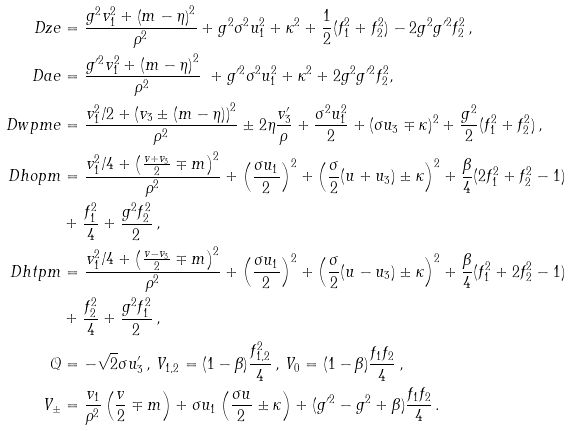<formula> <loc_0><loc_0><loc_500><loc_500>\ D z e & = \frac { g ^ { 2 } v _ { 1 } ^ { 2 } + \left ( m - \eta \right ) ^ { 2 } } { \rho ^ { 2 } } + g ^ { 2 } \sigma ^ { 2 } u _ { 1 } ^ { 2 } + \kappa ^ { 2 } + \frac { 1 } { 2 } ( f _ { 1 } ^ { 2 } + f _ { 2 } ^ { 2 } ) - 2 g ^ { 2 } g ^ { \prime 2 } f _ { 2 } ^ { 2 } \, , \\ \ D a e & = \frac { g ^ { \prime 2 } v _ { 1 } ^ { 2 } + \left ( m - \eta \right ) ^ { 2 } } { \rho ^ { 2 } } \ + g ^ { \prime 2 } \sigma ^ { 2 } u _ { 1 } ^ { 2 } + \kappa ^ { 2 } + 2 g ^ { 2 } g ^ { \prime 2 } f _ { 2 } ^ { 2 } , \\ \ D w p m e & = \frac { v _ { 1 } ^ { 2 } / 2 + \left ( v _ { 3 } \pm ( m - \eta ) \right ) ^ { 2 } } { \rho ^ { 2 } } \pm 2 \eta \frac { v _ { 3 } ^ { \prime } } { \rho } + \frac { \sigma ^ { 2 } u _ { 1 } ^ { 2 } } { 2 } + ( \sigma u _ { 3 } \mp \kappa ) ^ { 2 } + \frac { g ^ { 2 } } { 2 } ( f _ { 1 } ^ { 2 } + f _ { 2 } ^ { 2 } ) \, , \\ \ D h o p m & = \frac { v _ { 1 } ^ { 2 } / 4 + \left ( \frac { v + v _ { 3 } } { 2 } \mp m \right ) ^ { 2 } } { \rho ^ { 2 } } + \left ( \frac { \sigma u _ { 1 } } { 2 } \right ) ^ { 2 } + \left ( \frac { \sigma } { 2 } ( u + u _ { 3 } ) \pm \kappa \right ) ^ { 2 } + \frac { \beta } { 4 } ( 2 f _ { 1 } ^ { 2 } + f _ { 2 } ^ { 2 } - 1 ) \\ & + \frac { f _ { 1 } ^ { 2 } } { 4 } + \frac { g ^ { 2 } f _ { 2 } ^ { 2 } } { 2 } \, , \\ \ D h t p m & = \frac { v _ { 1 } ^ { 2 } / 4 + \left ( \frac { v - v _ { 3 } } { 2 } \mp m \right ) ^ { 2 } } { \rho ^ { 2 } } + \left ( \frac { \sigma u _ { 1 } } { 2 } \right ) ^ { 2 } + \left ( \frac { \sigma } { 2 } ( u - u _ { 3 } ) \pm \kappa \right ) ^ { 2 } + \frac { \beta } { 4 } ( f _ { 1 } ^ { 2 } + 2 f _ { 2 } ^ { 2 } - 1 ) \\ & + \frac { f _ { 2 } ^ { 2 } } { 4 } + \frac { g ^ { 2 } f _ { 1 } ^ { 2 } } { 2 } \, , \\ \mathcal { Q } & = - \sqrt { 2 } \sigma u _ { 3 } ^ { \prime } \, , \, V _ { 1 , 2 } = ( 1 - \beta ) \frac { f _ { 1 , 2 } ^ { 2 } } { 4 } \, , \, V _ { 0 } = ( 1 - \beta ) \frac { f _ { 1 } f _ { 2 } } { 4 } \, , \\ V _ { \pm } & = \frac { v _ { 1 } } { \rho ^ { 2 } } \left ( \frac { v } { 2 } \mp m \right ) + \sigma u _ { 1 } \left ( \frac { \sigma u } { 2 } \pm \kappa \right ) + ( g ^ { \prime 2 } - g ^ { 2 } + \beta ) \frac { f _ { 1 } f _ { 2 } } { 4 } \, .</formula> 